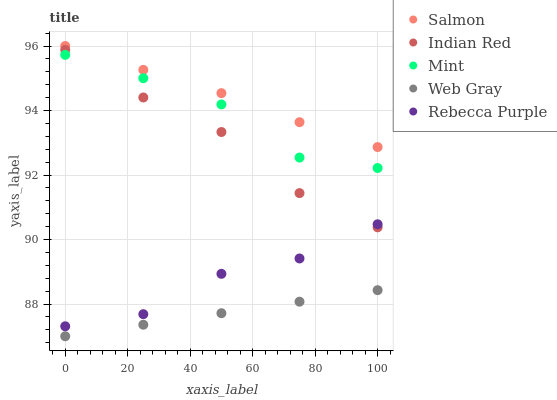Does Web Gray have the minimum area under the curve?
Answer yes or no. Yes. Does Salmon have the maximum area under the curve?
Answer yes or no. Yes. Does Salmon have the minimum area under the curve?
Answer yes or no. No. Does Web Gray have the maximum area under the curve?
Answer yes or no. No. Is Web Gray the smoothest?
Answer yes or no. Yes. Is Mint the roughest?
Answer yes or no. Yes. Is Salmon the smoothest?
Answer yes or no. No. Is Salmon the roughest?
Answer yes or no. No. Does Web Gray have the lowest value?
Answer yes or no. Yes. Does Salmon have the lowest value?
Answer yes or no. No. Does Salmon have the highest value?
Answer yes or no. Yes. Does Web Gray have the highest value?
Answer yes or no. No. Is Web Gray less than Rebecca Purple?
Answer yes or no. Yes. Is Salmon greater than Web Gray?
Answer yes or no. Yes. Does Indian Red intersect Rebecca Purple?
Answer yes or no. Yes. Is Indian Red less than Rebecca Purple?
Answer yes or no. No. Is Indian Red greater than Rebecca Purple?
Answer yes or no. No. Does Web Gray intersect Rebecca Purple?
Answer yes or no. No. 